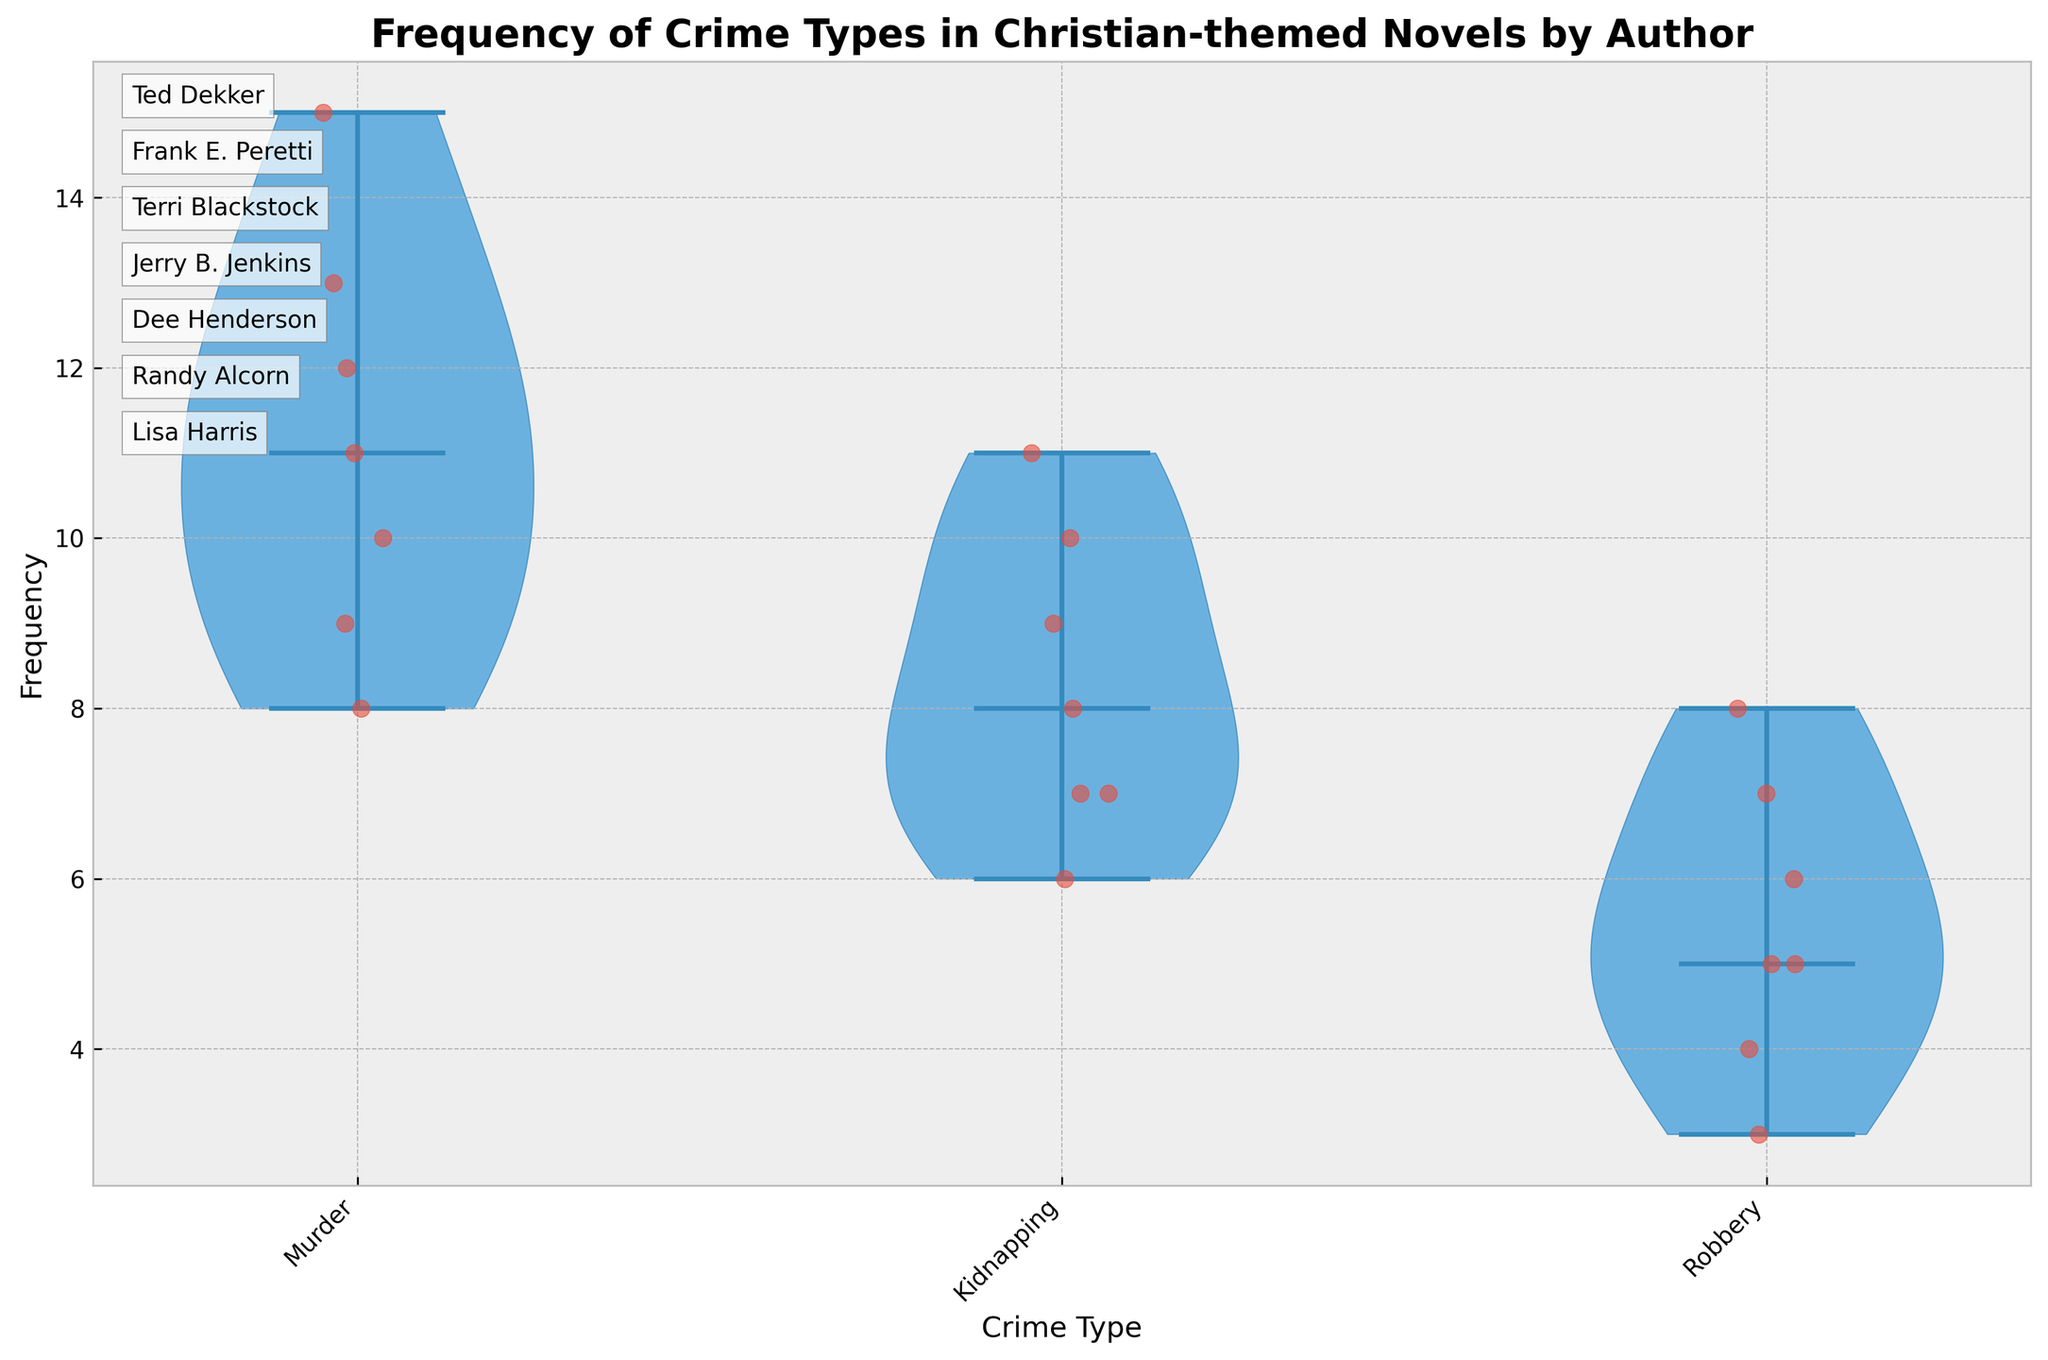What's the title of the plot? The title of the plot is found at the top center of the figure, usually in larger and bold font. It is designed to give the viewer a quick understanding of what the plot is about.
Answer: Frequency of Crime Types in Christian-themed Novels by Author How many types of crimes are represented in the plot? The types of crimes can be determined by the x-axis labels of the plot. Here, each unique label corresponds to a crime type.
Answer: 3 Which crime type has the highest median frequency? Medians are indicated by lines within each violin shape. By visually inspecting each crime type’s median line, the one with the highest position on the y-axis represents the highest median frequency.
Answer: Murder What is the approximate range of frequencies for Kidnapping in the plot? The range can be deduced from the spread of the violins and jittered points for Kidnapping. The top of the violin to the bottom gives the range.
Answer: 6 to 11 Which author is mentioned first in the list at the side of the plot? The author names are listed in text annotations along the side of the plot. The first name in that list is the answer.
Answer: Ted Dekker How does the spread of Murder frequencies compare to Robbery frequencies? The spread of frequencies can be observed by looking at the range within the violin plots for each crime type. Murder’s spread appears with a wider and longer shape than that of Robbery.
Answer: Murder has a wider spread than Robbery What is the median frequency of Robbery crimes? The median frequency can be identified by looking at the horizontal line within the violin for Robbery. This line represents the median value.
Answer: 6 Which crime type shows the most variation in frequency? Variation is indicated by the width and spread of the violin plots. The crime type with the widest and most spread-out shape shows the most variation.
Answer: Murder Is there any crime type where all authors have the same frequency? If yes, which one? Equality in frequencies would manifest as jittered points clustering closely around a single value within a violin. By inspecting the plot, you identify if such clustering exists.
Answer: No 